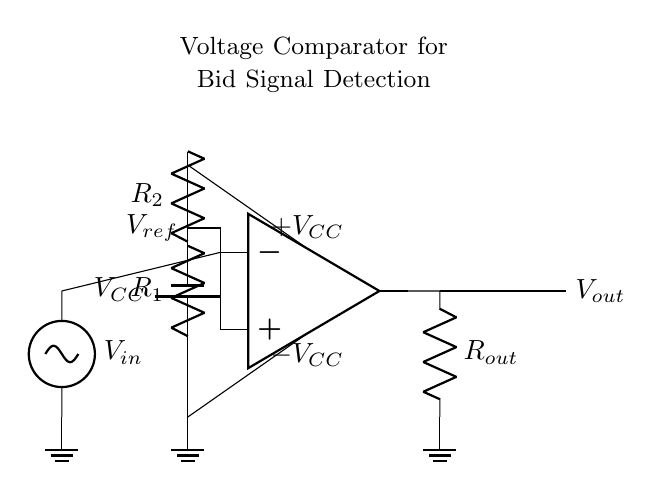What is the role of the op-amp in this circuit? The op-amp serves as a voltage comparator, analyzing the input voltage and comparing it to the reference voltage to determine the output state.
Answer: Voltage comparator What are the values of the resistors in the voltage divider? The resistors are labeled as R1 and R2; however, their specific values are not provided in the diagram.
Answer: R1 and R2 What is the output voltage indicated in the circuit? The output voltage is denoted as Vout, which represents the potential difference after the comparator processing.
Answer: Vout What is the purpose of the reference voltage? The reference voltage serves as a threshold level for the comparator, helping it decide whether the input voltage exceeds it.
Answer: Threshold level What is the input signal of this comparator circuit? The input signal is labeled as Vin, representing the varying voltage that will be compared against the reference voltage.
Answer: Vin What does the battery symbolize in this circuit diagram? The battery symbolizes the power supply (Vcc) that provides the necessary voltage for the operation of the op-amp and circuit.
Answer: Power supply Which components control the output of the comparator? The output of the comparator is controlled by the op-amp in conjunction with the reference voltage provided by the resistors R1 and R2.
Answer: Op-amp, R1, R2 